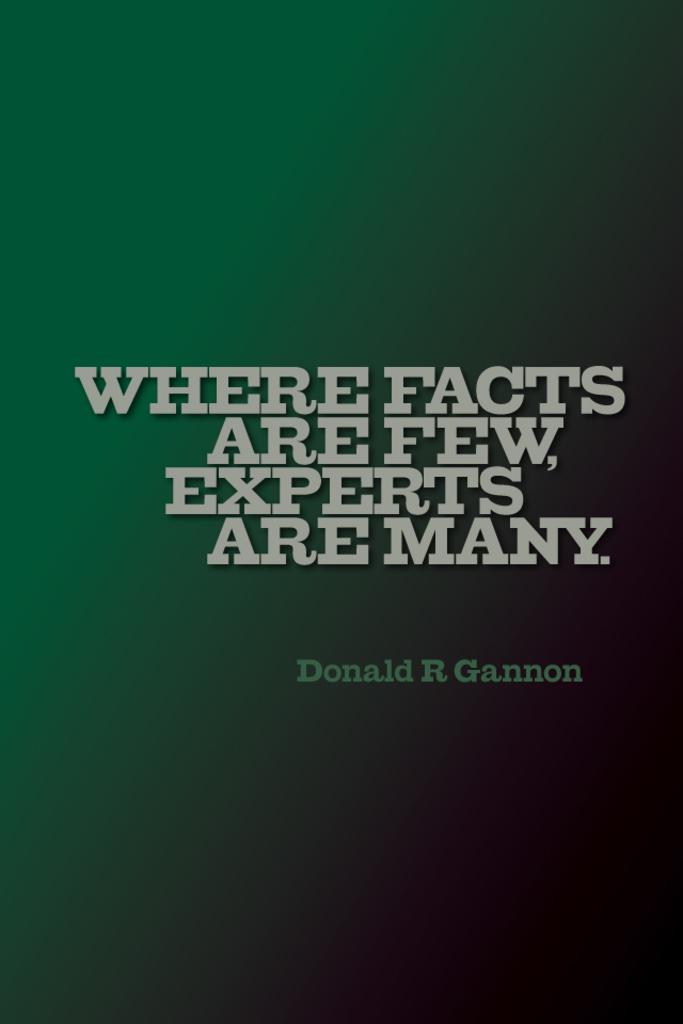<image>
Present a compact description of the photo's key features. A poster that says, "Where facts are few, experts are many." 